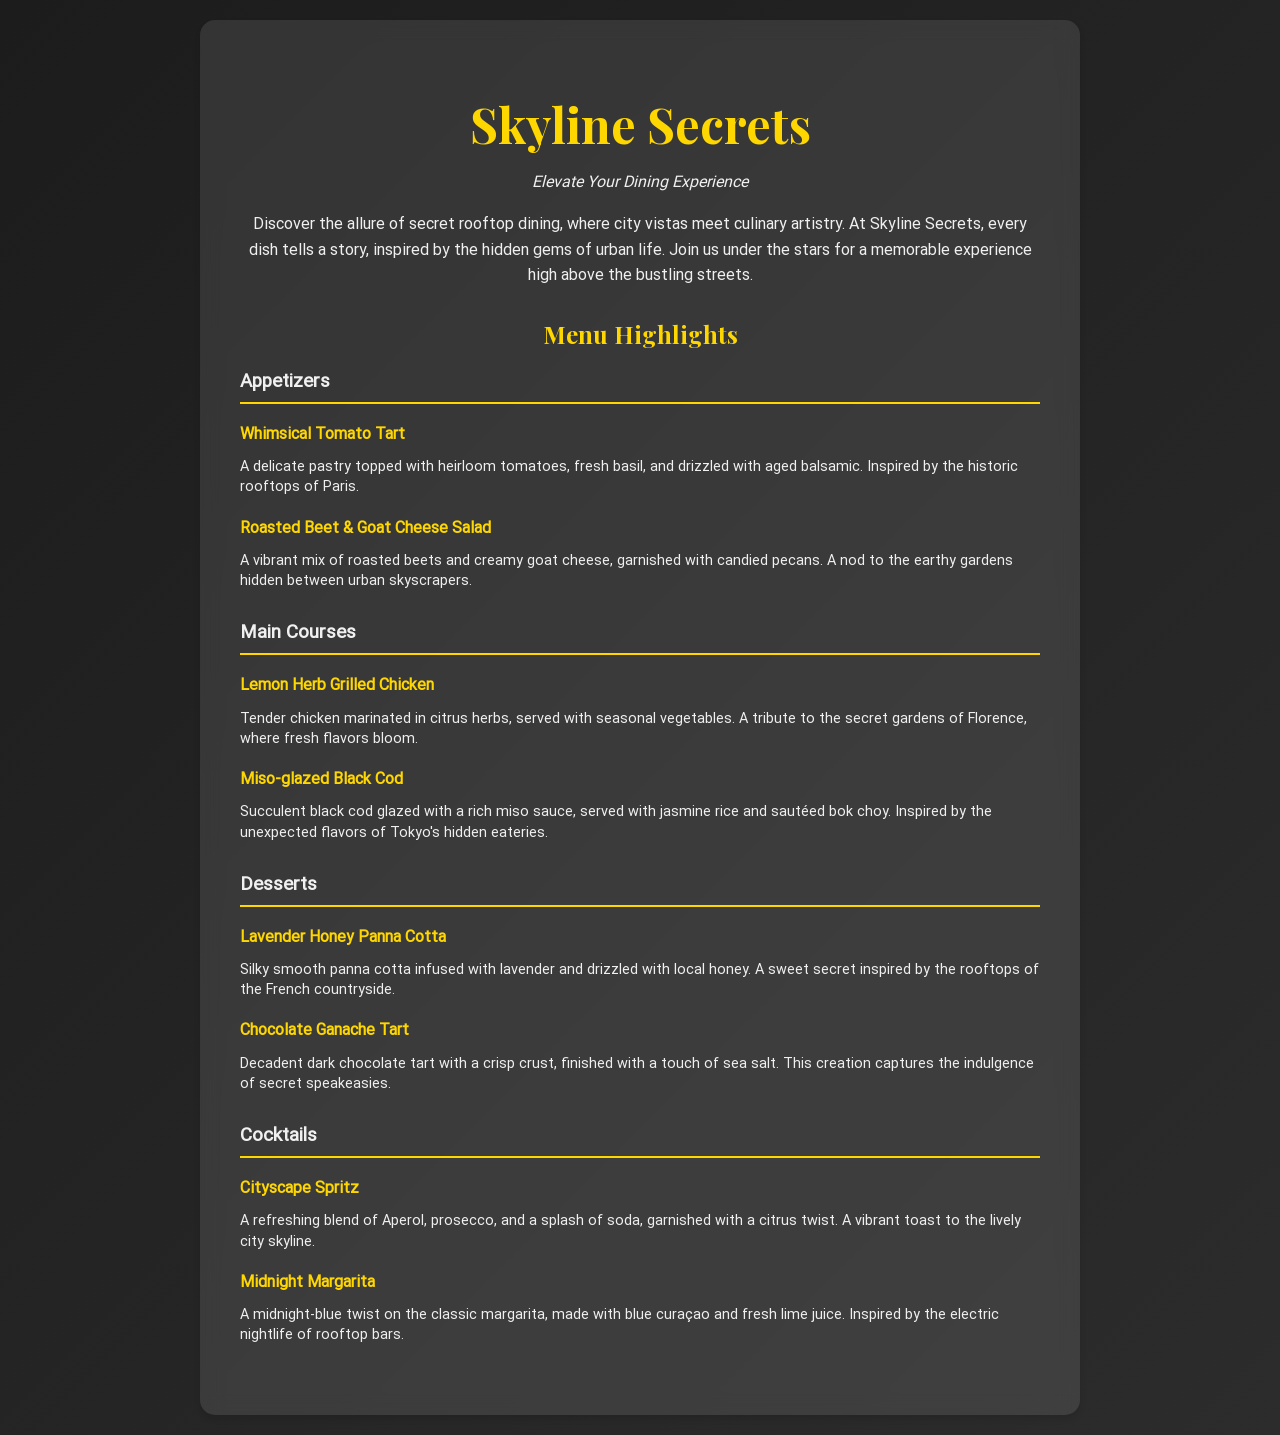What is the name of the restaurant? The name of the restaurant is presented prominently at the top of the menu.
Answer: Skyline Secrets What type of cuisine does Skyline Secrets offer? The menu describes a specific dining experience inspired by urban life and its hidden gems.
Answer: Rooftop dining What is the first appetizer listed? The first item in the appetizers section is noted for its delicate pastry and heirloom tomatoes.
Answer: Whimsical Tomato Tart What is the main ingredient in the Miso-glazed Black Cod? The description of the dish highlights the key flavor component used for glazing the fish.
Answer: Miso sauce Which dessert is inspired by the rooftops of the French countryside? The menu provides a brief context in the dessert section, associating a particular dessert with France.
Answer: Lavender Honey Panna Cotta How many sections are there in the menu? The number of distinct categories for the menu items can be counted within the document.
Answer: Four What cocktail is a twist on the classic margarita? The drink names are specified in the cocktails section, with one noted as a classic with a unique variation.
Answer: Midnight Margarita Which appetizer features creamy goat cheese? The details in the appetizers section list a specific dish that includes this ingredient.
Answer: Roasted Beet & Goat Cheese Salad What is the garnish for the Cityscape Spritz? The description of the cocktail states an ingredient used for garnishing.
Answer: Citrus twist 